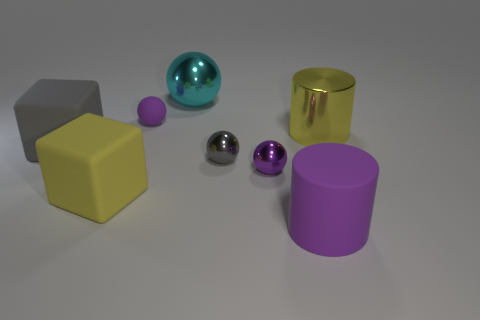Subtract all tiny purple rubber balls. How many balls are left? 3 Add 1 gray things. How many objects exist? 9 Subtract all gray spheres. How many spheres are left? 3 Subtract all cylinders. How many objects are left? 6 Subtract 1 cylinders. How many cylinders are left? 1 Subtract all blue cubes. How many yellow cylinders are left? 1 Subtract all big cyan cylinders. Subtract all blocks. How many objects are left? 6 Add 3 large matte objects. How many large matte objects are left? 6 Add 7 big gray cubes. How many big gray cubes exist? 8 Subtract 0 cyan cubes. How many objects are left? 8 